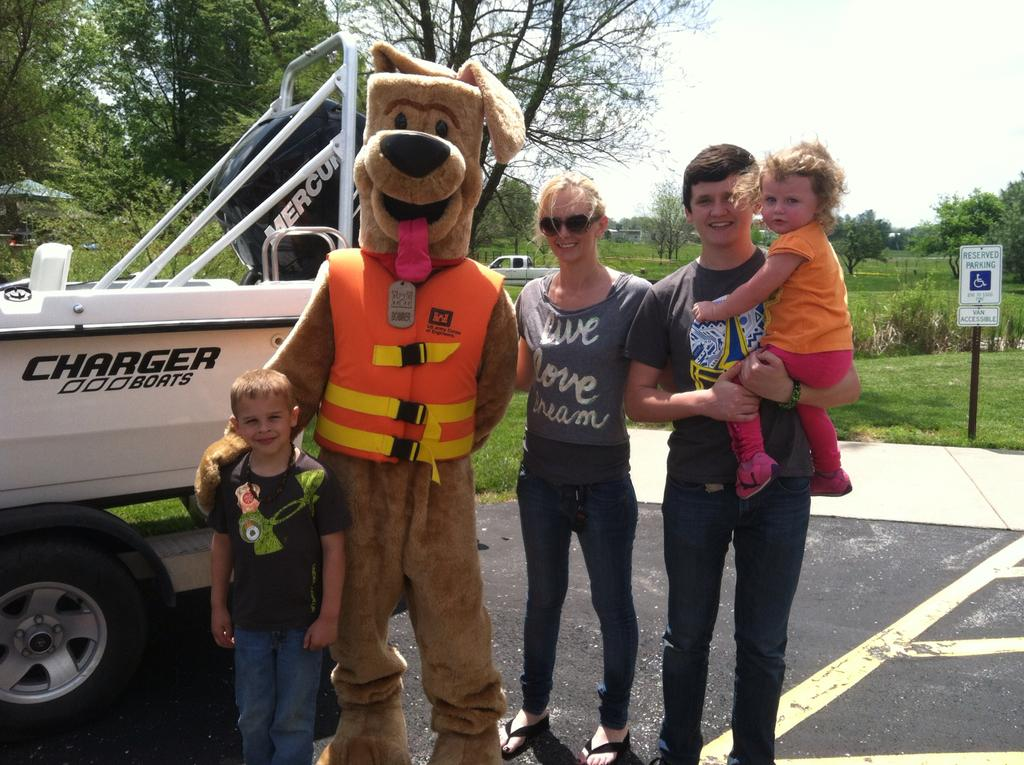What are the people in the image doing? The people in the image are standing on the road and smiling. What else can be seen in the image besides the people? There are vehicles, trees, a signboard, grass, and the sky visible in the image. What might the signboard be used for? The signboard in the image could be used for providing information or directions. What is the condition of the sky in the image? The sky is visible in the background of the image, and its condition is not specified. What type of bead is being used for digestion in the image? There is no bead or reference to digestion present in the image. 